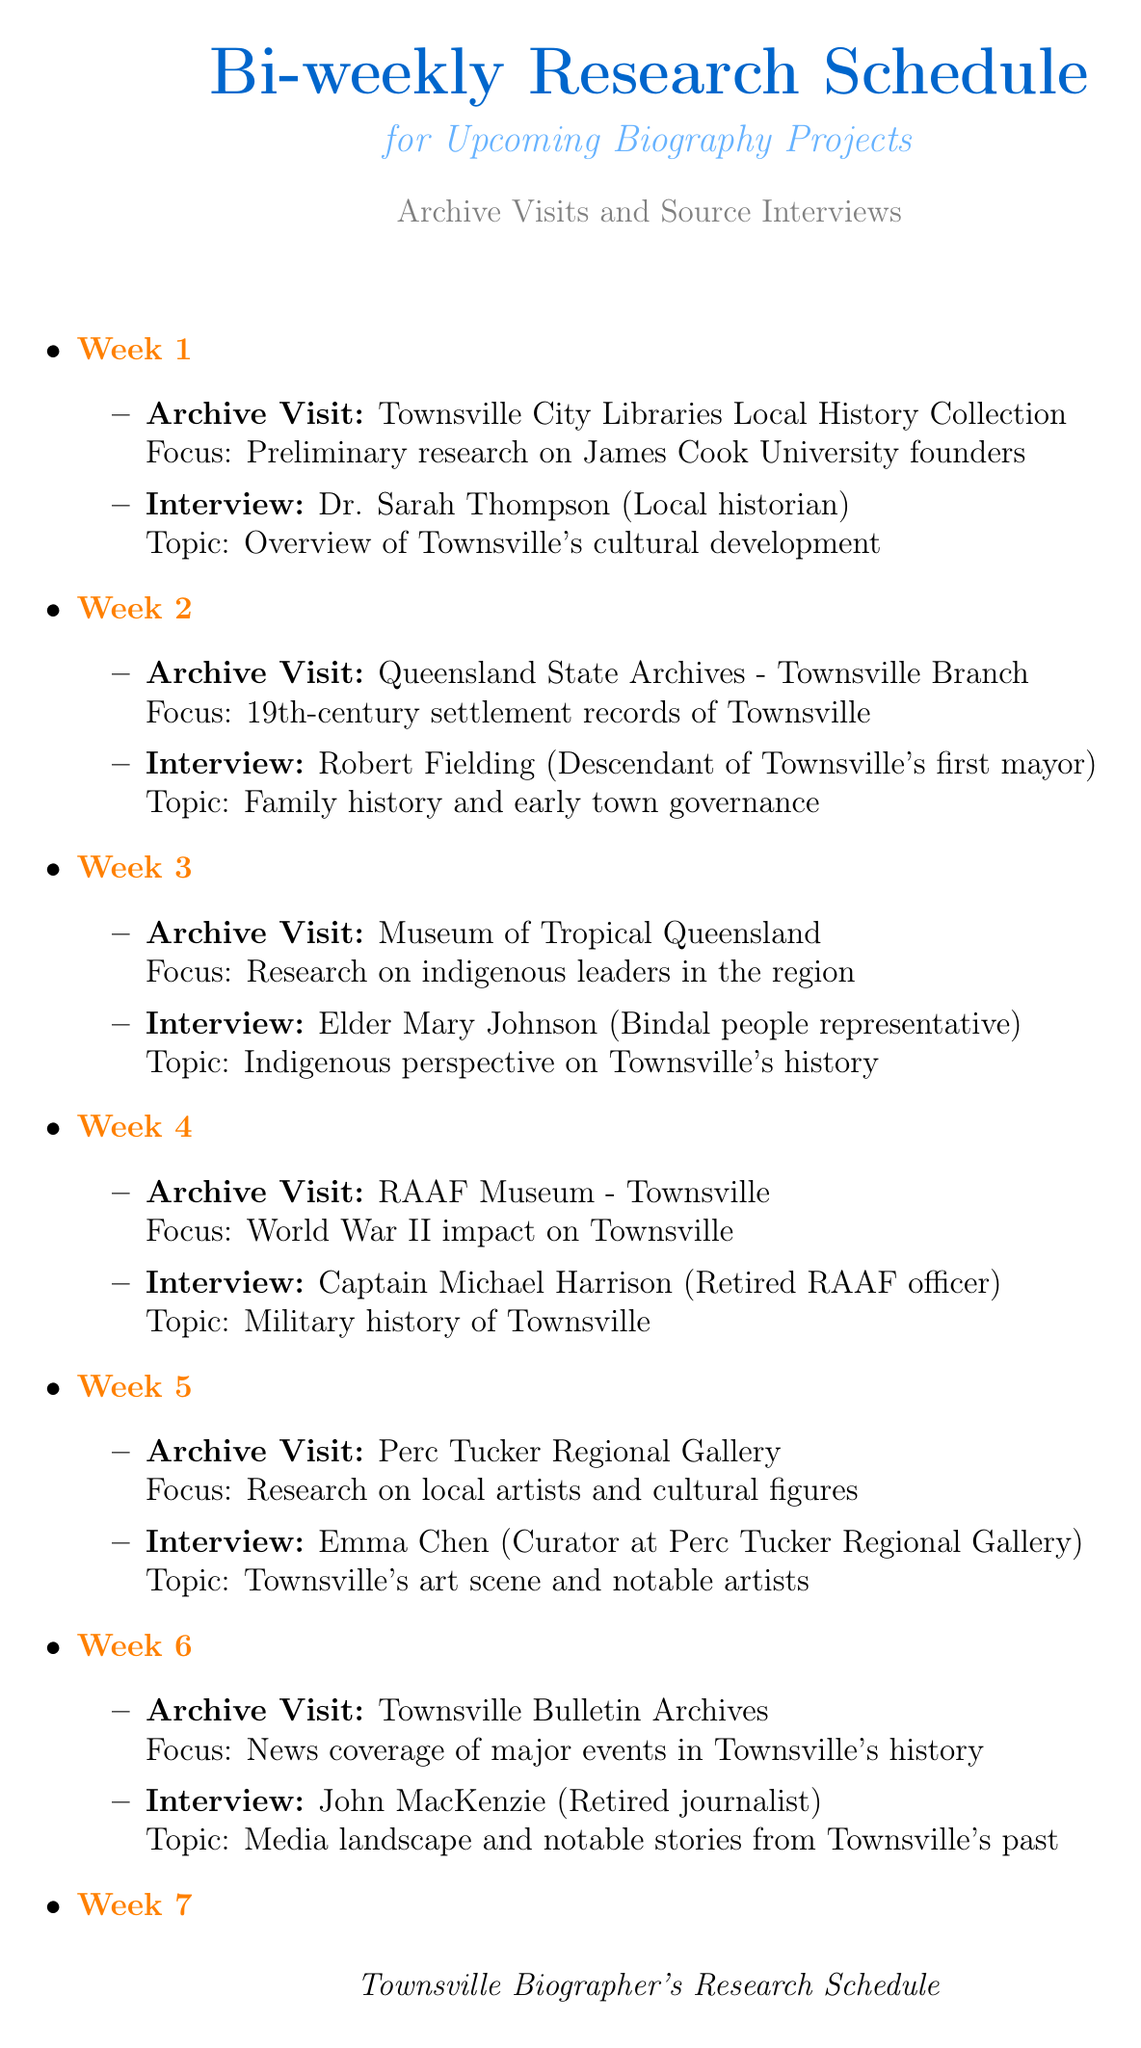What is the focus of the archive visit in Week 1? The focus for Week 1 is stated in the document as "Preliminary research on James Cook University founders."
Answer: Preliminary research on James Cook University founders Who is the interview subject in Week 3? The document specifies that the interview subject for Week 3 is "Elder Mary Johnson."
Answer: Elder Mary Johnson What is the archival focus during Week 5? Week 5's archival focus is specified as "Research on local artists and cultural figures."
Answer: Research on local artists and cultural figures Which location is visited for archive research in Week 6? The document indicates that the archive visit in Week 6 is to the "Townsville Bulletin Archives."
Answer: Townsville Bulletin Archives What role does Captain Lisa Brown hold? According to the document, Captain Lisa Brown's role is noted as "Harbour Master."
Answer: Harbour Master In which week is the interview with Dr. Sarah Thompson scheduled? The document lists Dr. Sarah Thompson's interview as taking place in Week 1.
Answer: Week 1 How many weeks does the research schedule cover? The document outlines activities across "8 weeks," detailing the schedule.
Answer: 8 weeks What is the topic of the interview with Johnathan Thurston? The document specifies that the topic of Johnathan Thurston’s interview is "Sports history and community impact in Townsville."
Answer: Sports history and community impact in Townsville What is the singular focus of the archive visit for Week 4? The document states that the focus for Week 4 is on the "World War II impact on Townsville."
Answer: World War II impact on Townsville 